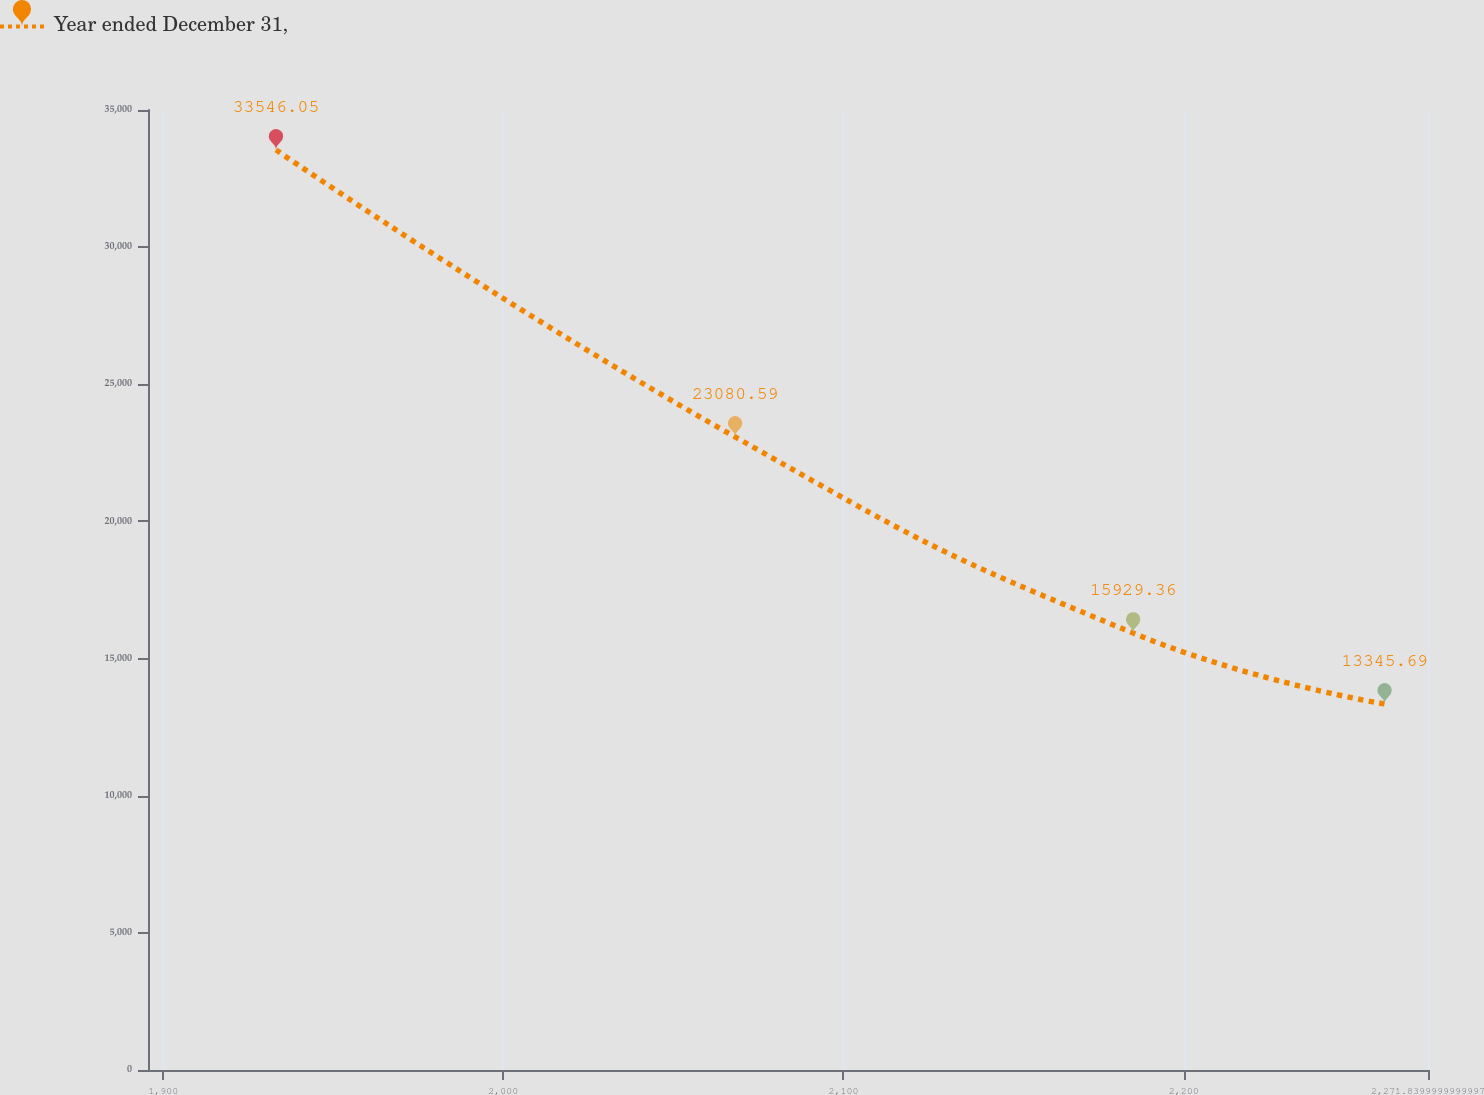<chart> <loc_0><loc_0><loc_500><loc_500><line_chart><ecel><fcel>Year ended December 31,<nl><fcel>1933.17<fcel>33546.1<nl><fcel>2068.15<fcel>23080.6<nl><fcel>2185.16<fcel>15929.4<nl><fcel>2259.09<fcel>13345.7<nl><fcel>2309.47<fcel>7709.33<nl></chart> 